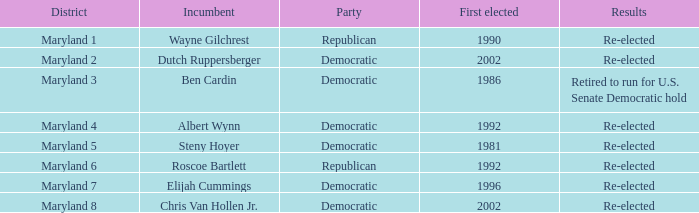What are the results of the incumbent who was first elected in 1996? Re-elected. Give me the full table as a dictionary. {'header': ['District', 'Incumbent', 'Party', 'First elected', 'Results'], 'rows': [['Maryland 1', 'Wayne Gilchrest', 'Republican', '1990', 'Re-elected'], ['Maryland 2', 'Dutch Ruppersberger', 'Democratic', '2002', 'Re-elected'], ['Maryland 3', 'Ben Cardin', 'Democratic', '1986', 'Retired to run for U.S. Senate Democratic hold'], ['Maryland 4', 'Albert Wynn', 'Democratic', '1992', 'Re-elected'], ['Maryland 5', 'Steny Hoyer', 'Democratic', '1981', 'Re-elected'], ['Maryland 6', 'Roscoe Bartlett', 'Republican', '1992', 'Re-elected'], ['Maryland 7', 'Elijah Cummings', 'Democratic', '1996', 'Re-elected'], ['Maryland 8', 'Chris Van Hollen Jr.', 'Democratic', '2002', 'Re-elected']]} 